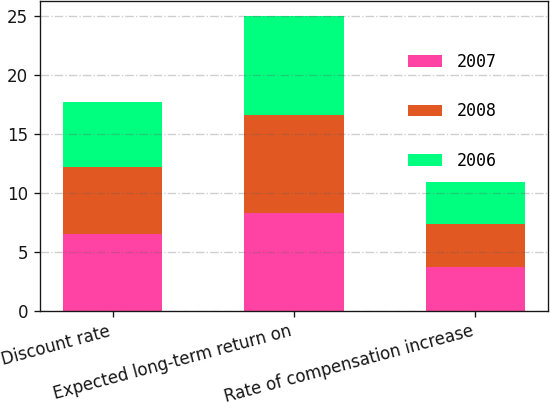Convert chart to OTSL. <chart><loc_0><loc_0><loc_500><loc_500><stacked_bar_chart><ecel><fcel>Discount rate<fcel>Expected long-term return on<fcel>Rate of compensation increase<nl><fcel>2007<fcel>6.47<fcel>8.29<fcel>3.7<nl><fcel>2008<fcel>5.74<fcel>8.3<fcel>3.63<nl><fcel>2006<fcel>5.49<fcel>8.39<fcel>3.6<nl></chart> 